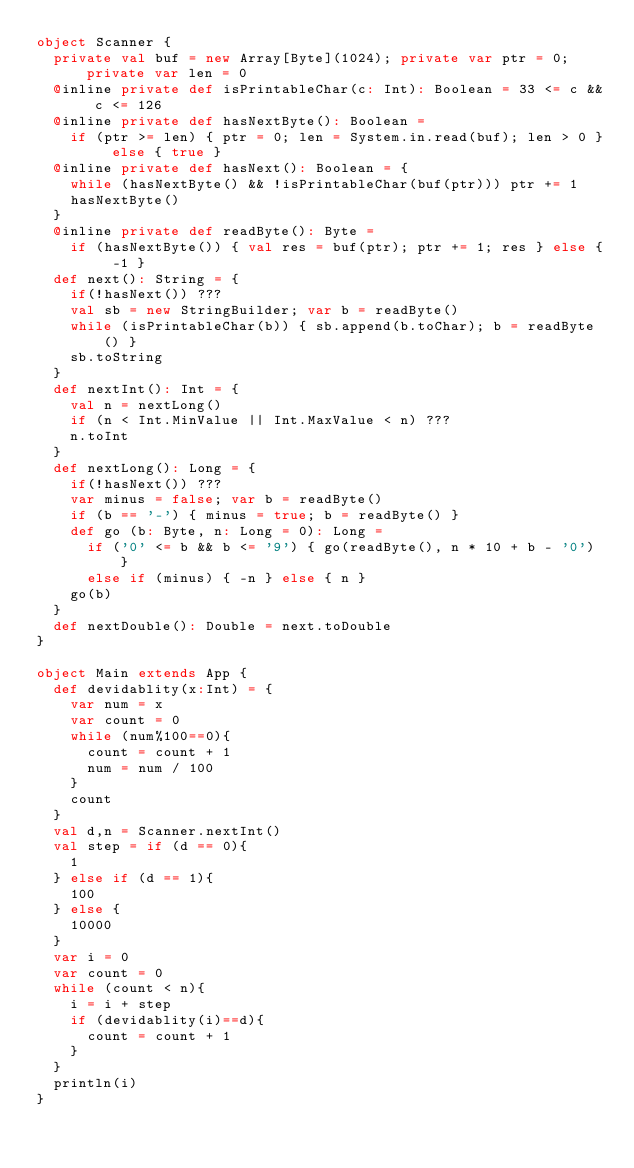<code> <loc_0><loc_0><loc_500><loc_500><_Scala_>object Scanner {
  private val buf = new Array[Byte](1024); private var ptr = 0; private var len = 0
  @inline private def isPrintableChar(c: Int): Boolean = 33 <= c && c <= 126
  @inline private def hasNextByte(): Boolean =
    if (ptr >= len) { ptr = 0; len = System.in.read(buf); len > 0 } else { true }
  @inline private def hasNext(): Boolean = {
    while (hasNextByte() && !isPrintableChar(buf(ptr))) ptr += 1
    hasNextByte()
  }
  @inline private def readByte(): Byte =
    if (hasNextByte()) { val res = buf(ptr); ptr += 1; res } else { -1 }
  def next(): String = {
    if(!hasNext()) ???
    val sb = new StringBuilder; var b = readByte()
    while (isPrintableChar(b)) { sb.append(b.toChar); b = readByte() }
    sb.toString
  }
  def nextInt(): Int = {
    val n = nextLong()
    if (n < Int.MinValue || Int.MaxValue < n) ???
    n.toInt
  }
  def nextLong(): Long = {
    if(!hasNext()) ???
    var minus = false; var b = readByte()
    if (b == '-') { minus = true; b = readByte() }
    def go (b: Byte, n: Long = 0): Long =
      if ('0' <= b && b <= '9') { go(readByte(), n * 10 + b - '0') }
      else if (minus) { -n } else { n }
    go(b)
  }
  def nextDouble(): Double = next.toDouble
}

object Main extends App {
  def devidablity(x:Int) = {
    var num = x
    var count = 0
    while (num%100==0){
      count = count + 1
      num = num / 100
    }
    count
  }
  val d,n = Scanner.nextInt()
  val step = if (d == 0){
    1
  } else if (d == 1){
    100
  } else {
    10000
  }
  var i = 0
  var count = 0
  while (count < n){
    i = i + step
    if (devidablity(i)==d){
      count = count + 1
    }
  }
  println(i)
}</code> 